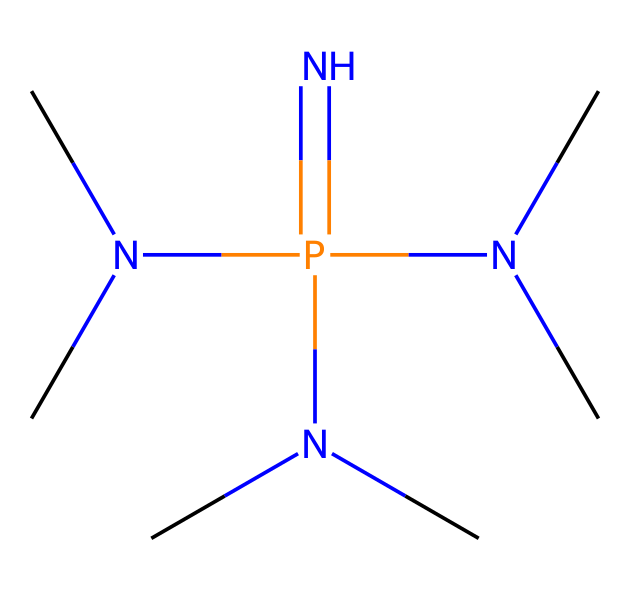What is the main element in this structure? The primary element in the SMILES representation is phosphorus, as indicated by the "P" in the structure.
Answer: phosphorus How many nitrogen atoms are present in the molecule? The SMILES notation includes four "N" characters, indicating that there are four nitrogen atoms in the structure.
Answer: four What type of base is represented by this molecule? Phosphazene bases are classified as non-ionic superbases, as characterized by the presence of multiple nitrogen substituents surrounding a phosphorus atom.
Answer: non-ionic superbase What is the connectivity between the nitrogen atoms and the phosphorus atom? In the structure, each nitrogen atom is bonded directly to the phosphorus atom, forming a central phosphorus atom surrounded by nitrogen atoms in a tetrahedral manner.
Answer: tetrahedral How many substituents are attached to the phosphorus atom? There are three N(C)C substituents attached to the phosphorus atom, formed by the branching of nitrogen atoms where each nitrogen is connected to a carbon group.
Answer: three Which property of this class of superbases is a result of its structural arrangement? The structural arrangement, featuring multiple nitrogen atoms closely associated with phosphorus, contributes to its strong basicity due to the electron-donating ability of the nitrogen atoms.
Answer: strong basicity 